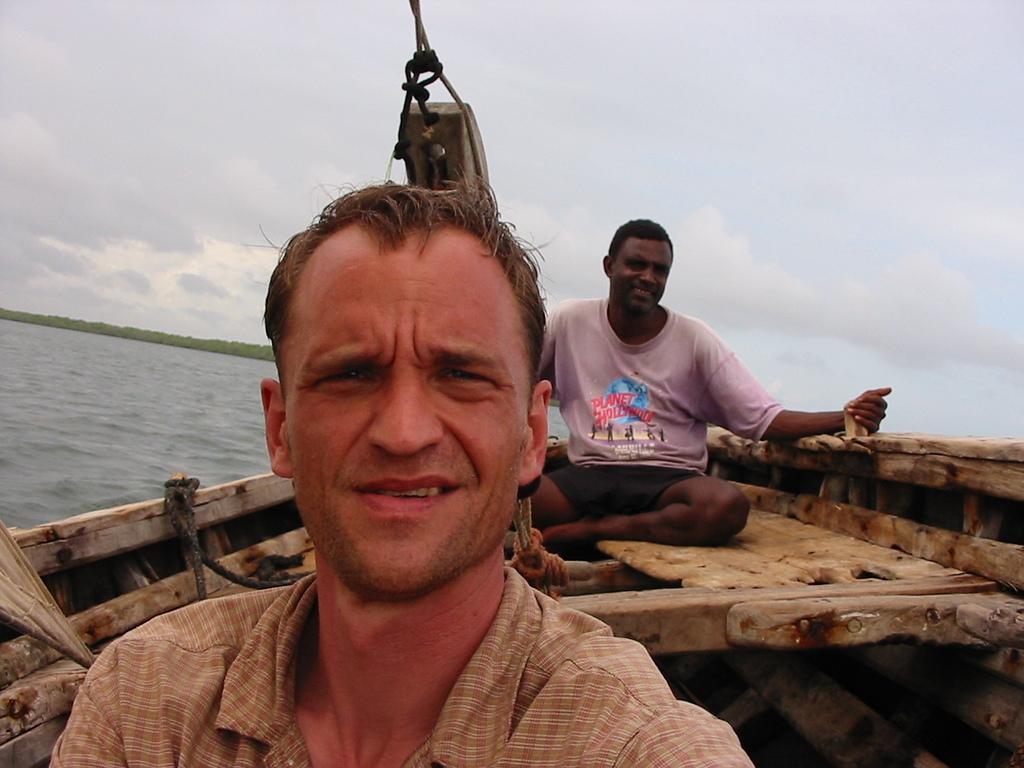How would you summarize this image in a sentence or two? The picture is clicked in a boat. In the foreground of the picture there are two men sitting in a boat. On the left there is water and greenery. Sky is cloudy. 